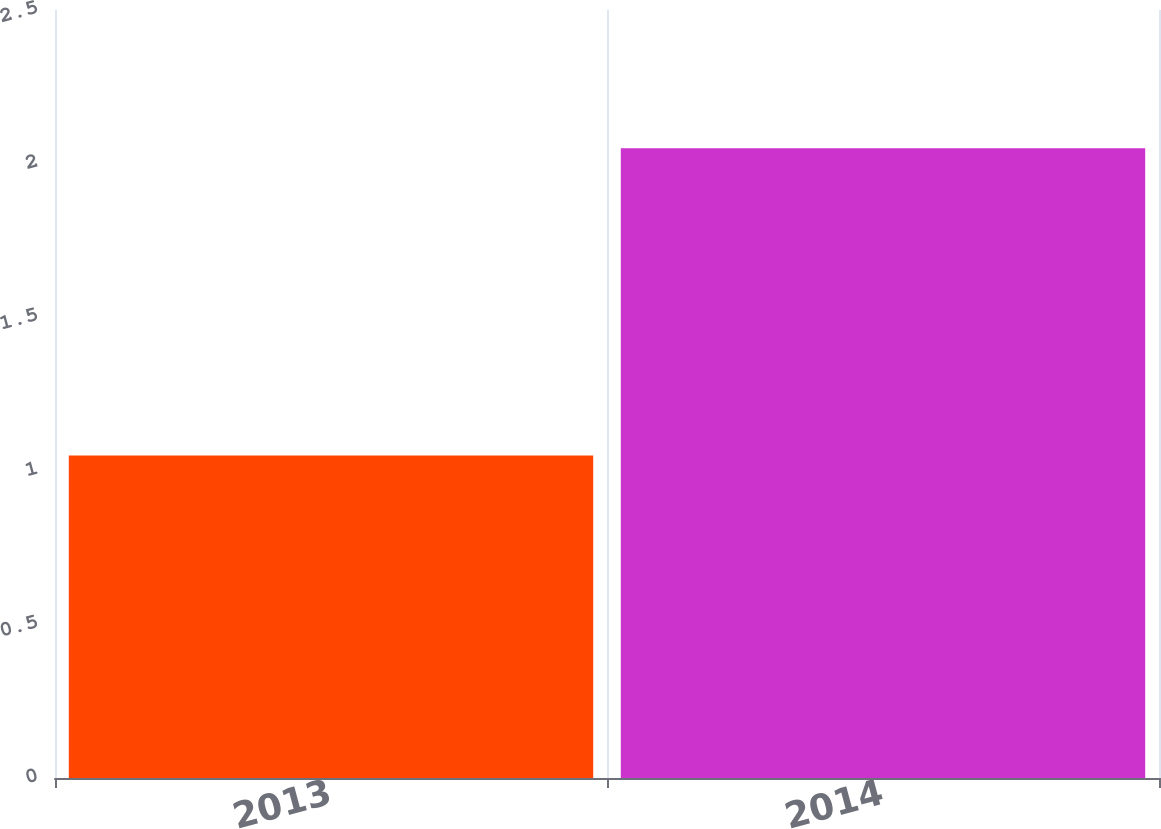Convert chart. <chart><loc_0><loc_0><loc_500><loc_500><bar_chart><fcel>2013<fcel>2014<nl><fcel>1.05<fcel>2.05<nl></chart> 